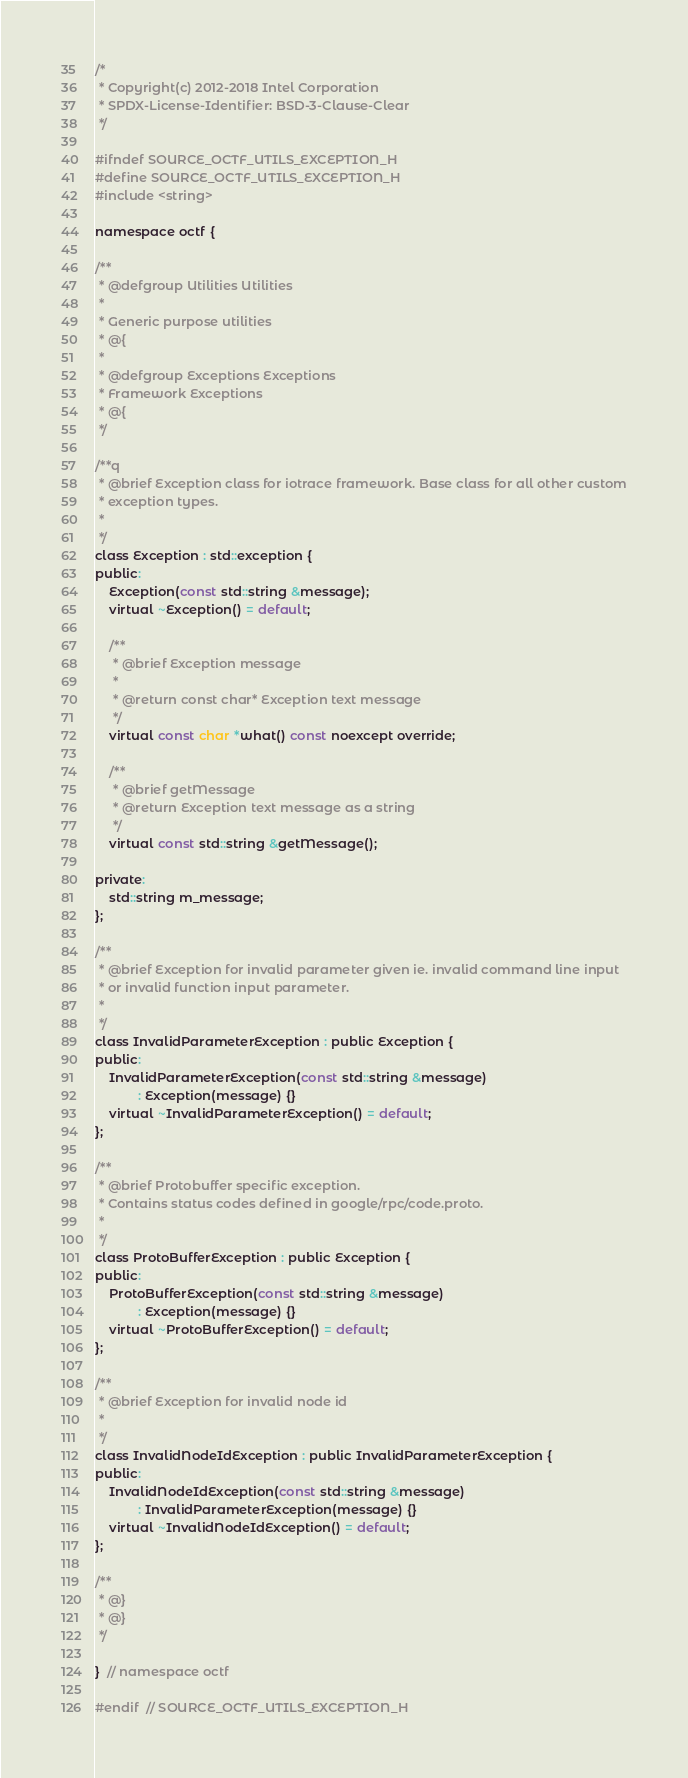<code> <loc_0><loc_0><loc_500><loc_500><_C_>/*
 * Copyright(c) 2012-2018 Intel Corporation
 * SPDX-License-Identifier: BSD-3-Clause-Clear
 */

#ifndef SOURCE_OCTF_UTILS_EXCEPTION_H
#define SOURCE_OCTF_UTILS_EXCEPTION_H
#include <string>

namespace octf {

/**
 * @defgroup Utilities Utilities
 *
 * Generic purpose utilities
 * @{
 *
 * @defgroup Exceptions Exceptions
 * Framework Exceptions
 * @{
 */

/**q
 * @brief Exception class for iotrace framework. Base class for all other custom
 * exception types.
 *
 */
class Exception : std::exception {
public:
    Exception(const std::string &message);
    virtual ~Exception() = default;

    /**
     * @brief Exception message
     *
     * @return const char* Exception text message
     */
    virtual const char *what() const noexcept override;

    /**
     * @brief getMessage
     * @return Exception text message as a string
     */
    virtual const std::string &getMessage();

private:
    std::string m_message;
};

/**
 * @brief Exception for invalid parameter given ie. invalid command line input
 * or invalid function input parameter.
 *
 */
class InvalidParameterException : public Exception {
public:
    InvalidParameterException(const std::string &message)
            : Exception(message) {}
    virtual ~InvalidParameterException() = default;
};

/**
 * @brief Protobuffer specific exception.
 * Contains status codes defined in google/rpc/code.proto.
 *
 */
class ProtoBufferException : public Exception {
public:
    ProtoBufferException(const std::string &message)
            : Exception(message) {}
    virtual ~ProtoBufferException() = default;
};

/**
 * @brief Exception for invalid node id
 *
 */
class InvalidNodeIdException : public InvalidParameterException {
public:
    InvalidNodeIdException(const std::string &message)
            : InvalidParameterException(message) {}
    virtual ~InvalidNodeIdException() = default;
};

/**
 * @}
 * @}
 */

}  // namespace octf

#endif  // SOURCE_OCTF_UTILS_EXCEPTION_H
</code> 